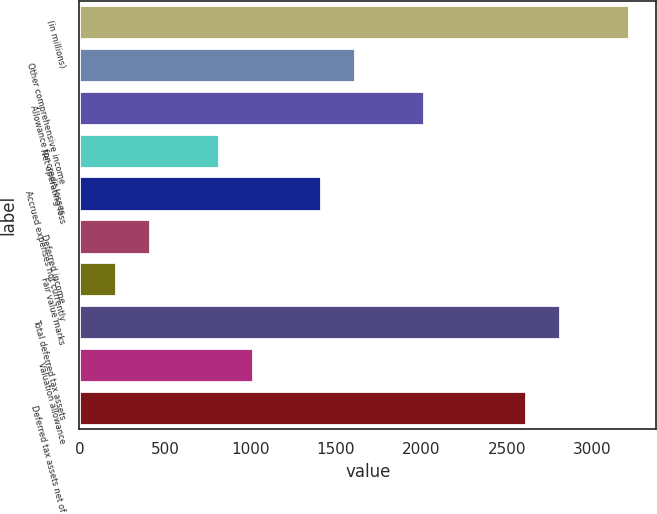Convert chart to OTSL. <chart><loc_0><loc_0><loc_500><loc_500><bar_chart><fcel>(in millions)<fcel>Other comprehensive income<fcel>Allowance for credit losses<fcel>Net operating loss<fcel>Accrued expenses not currently<fcel>Deferred income<fcel>Fair value marks<fcel>Total deferred tax assets<fcel>Valuation allowance<fcel>Deferred tax assets net of<nl><fcel>3214<fcel>1614<fcel>2014<fcel>814<fcel>1414<fcel>414<fcel>214<fcel>2814<fcel>1014<fcel>2614<nl></chart> 